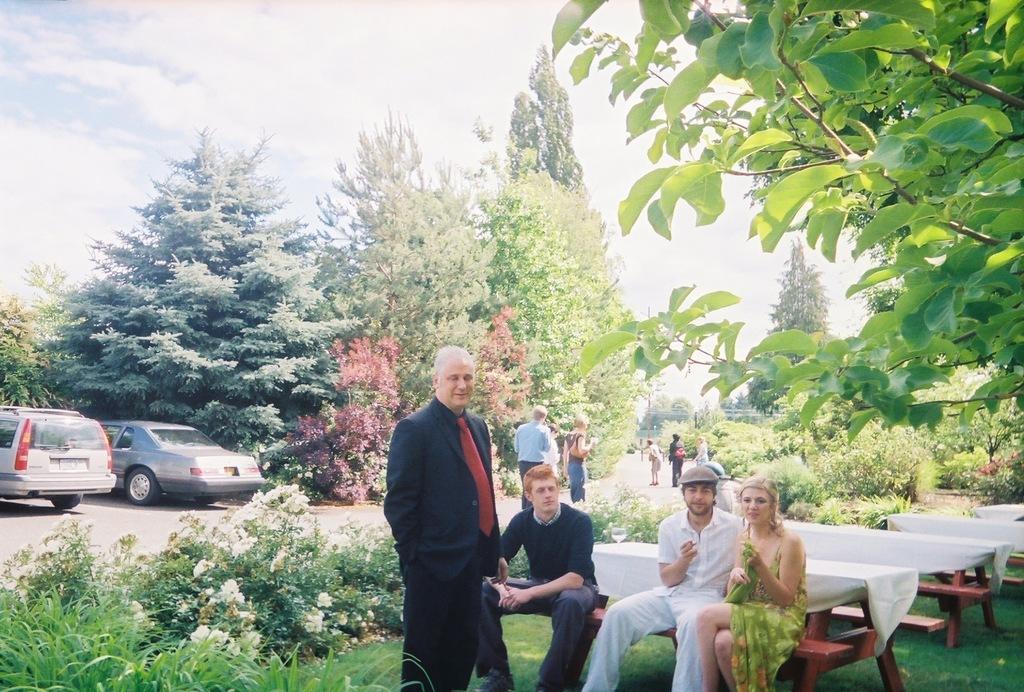In one or two sentences, can you explain what this image depicts? In the foreground of the picture I can see four persons. I can see three of them sitting on the wooden bench. There is a man standing and he is wearing a suit and tie. I can see the tables on the floor and covered with white cloth. I can see two cars parked in a parking space on the left side. In the background, I can see a few persons on the road, trees and flowering plants. 